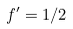<formula> <loc_0><loc_0><loc_500><loc_500>f ^ { \prime } = 1 / 2</formula> 